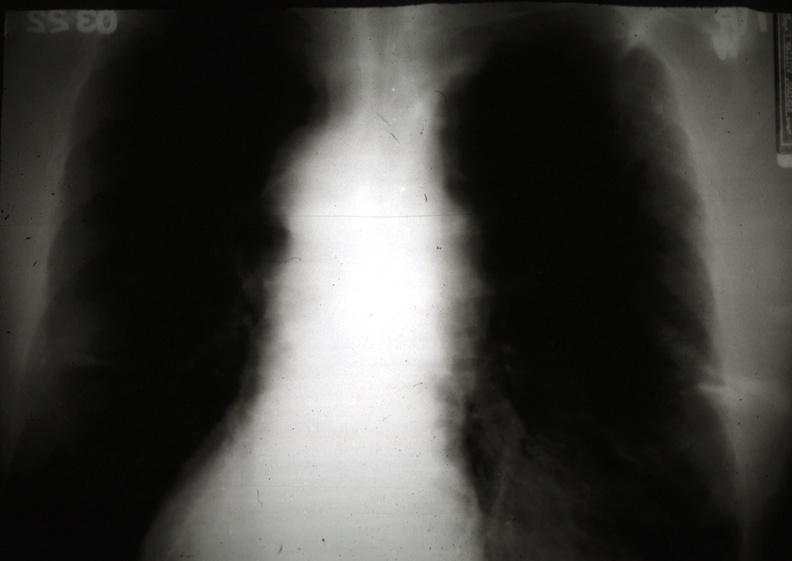what does this image show?
Answer the question using a single word or phrase. X-ray chest showing mediastinal widening and fuzzy border 